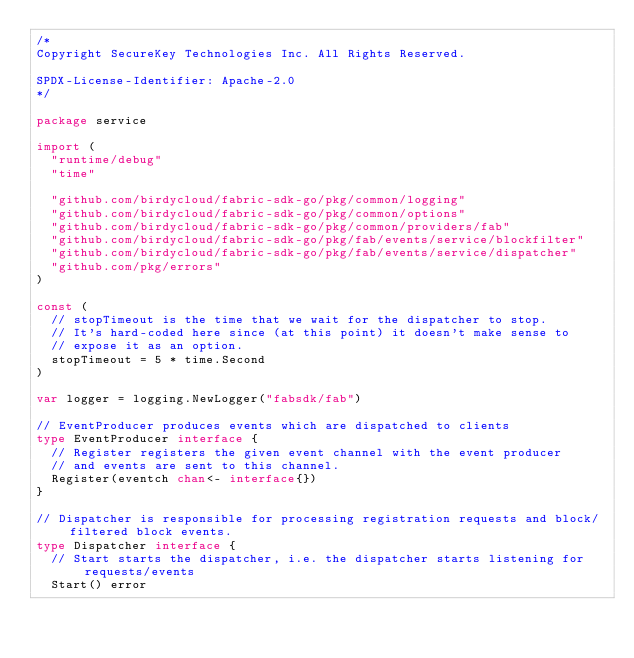<code> <loc_0><loc_0><loc_500><loc_500><_Go_>/*
Copyright SecureKey Technologies Inc. All Rights Reserved.

SPDX-License-Identifier: Apache-2.0
*/

package service

import (
	"runtime/debug"
	"time"

	"github.com/birdycloud/fabric-sdk-go/pkg/common/logging"
	"github.com/birdycloud/fabric-sdk-go/pkg/common/options"
	"github.com/birdycloud/fabric-sdk-go/pkg/common/providers/fab"
	"github.com/birdycloud/fabric-sdk-go/pkg/fab/events/service/blockfilter"
	"github.com/birdycloud/fabric-sdk-go/pkg/fab/events/service/dispatcher"
	"github.com/pkg/errors"
)

const (
	// stopTimeout is the time that we wait for the dispatcher to stop.
	// It's hard-coded here since (at this point) it doesn't make sense to
	// expose it as an option.
	stopTimeout = 5 * time.Second
)

var logger = logging.NewLogger("fabsdk/fab")

// EventProducer produces events which are dispatched to clients
type EventProducer interface {
	// Register registers the given event channel with the event producer
	// and events are sent to this channel.
	Register(eventch chan<- interface{})
}

// Dispatcher is responsible for processing registration requests and block/filtered block events.
type Dispatcher interface {
	// Start starts the dispatcher, i.e. the dispatcher starts listening for requests/events
	Start() error
</code> 